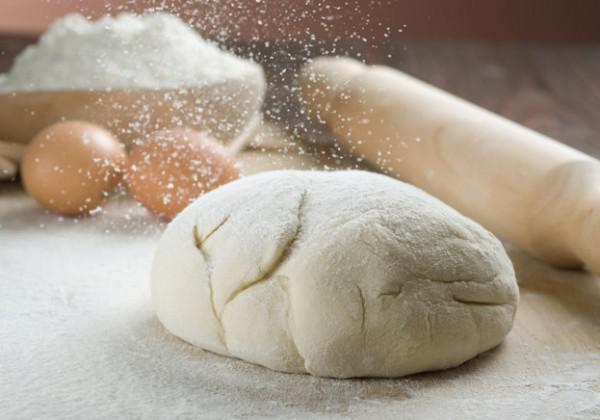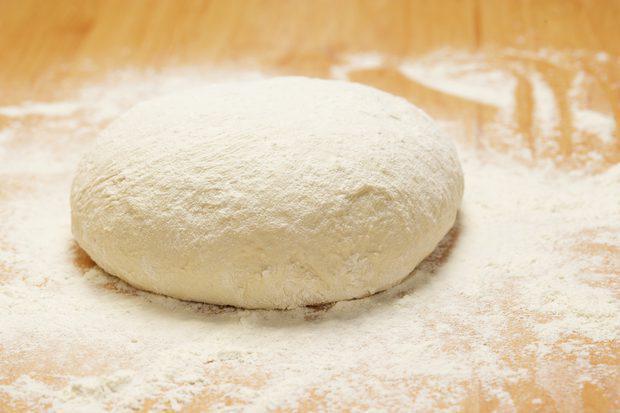The first image is the image on the left, the second image is the image on the right. Given the left and right images, does the statement "Each image contains one rounded ball of dough on a floured surface, with no hands touching the ball." hold true? Answer yes or no. Yes. 